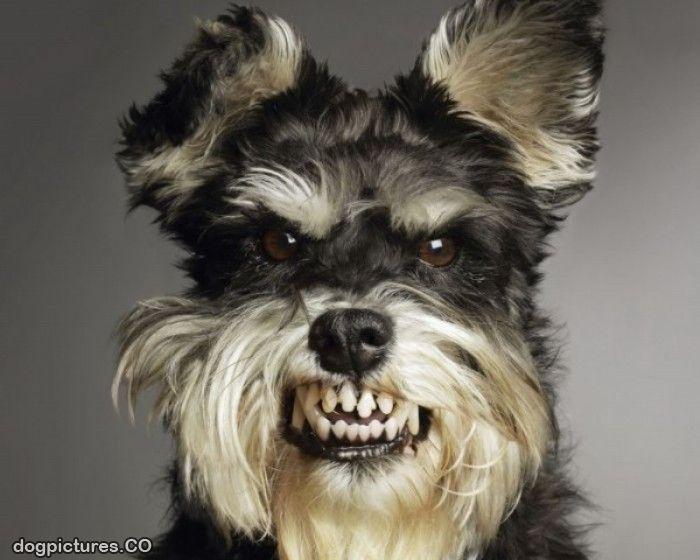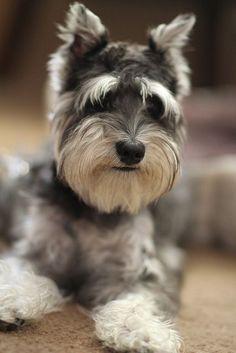The first image is the image on the left, the second image is the image on the right. For the images shown, is this caption "A dog poses in one of the images, on a table, in front of a green wall." true? Answer yes or no. No. The first image is the image on the left, the second image is the image on the right. Evaluate the accuracy of this statement regarding the images: "the right image has a dog on a gray floor mat and green walls". Is it true? Answer yes or no. No. 